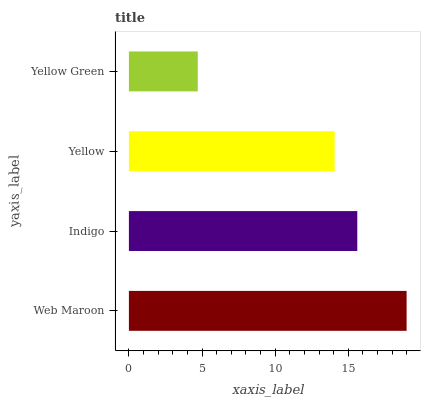Is Yellow Green the minimum?
Answer yes or no. Yes. Is Web Maroon the maximum?
Answer yes or no. Yes. Is Indigo the minimum?
Answer yes or no. No. Is Indigo the maximum?
Answer yes or no. No. Is Web Maroon greater than Indigo?
Answer yes or no. Yes. Is Indigo less than Web Maroon?
Answer yes or no. Yes. Is Indigo greater than Web Maroon?
Answer yes or no. No. Is Web Maroon less than Indigo?
Answer yes or no. No. Is Indigo the high median?
Answer yes or no. Yes. Is Yellow the low median?
Answer yes or no. Yes. Is Yellow Green the high median?
Answer yes or no. No. Is Yellow Green the low median?
Answer yes or no. No. 